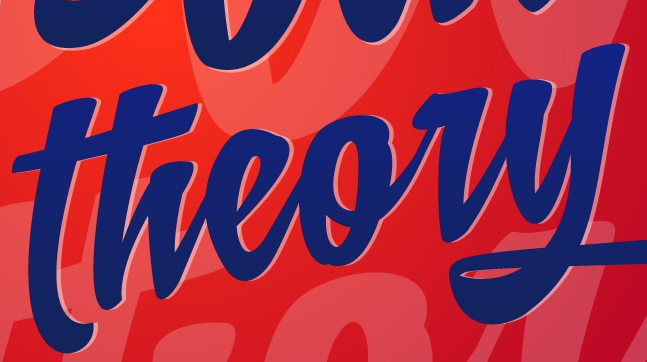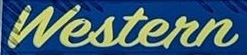What text is displayed in these images sequentially, separated by a semicolon? theory; Western 